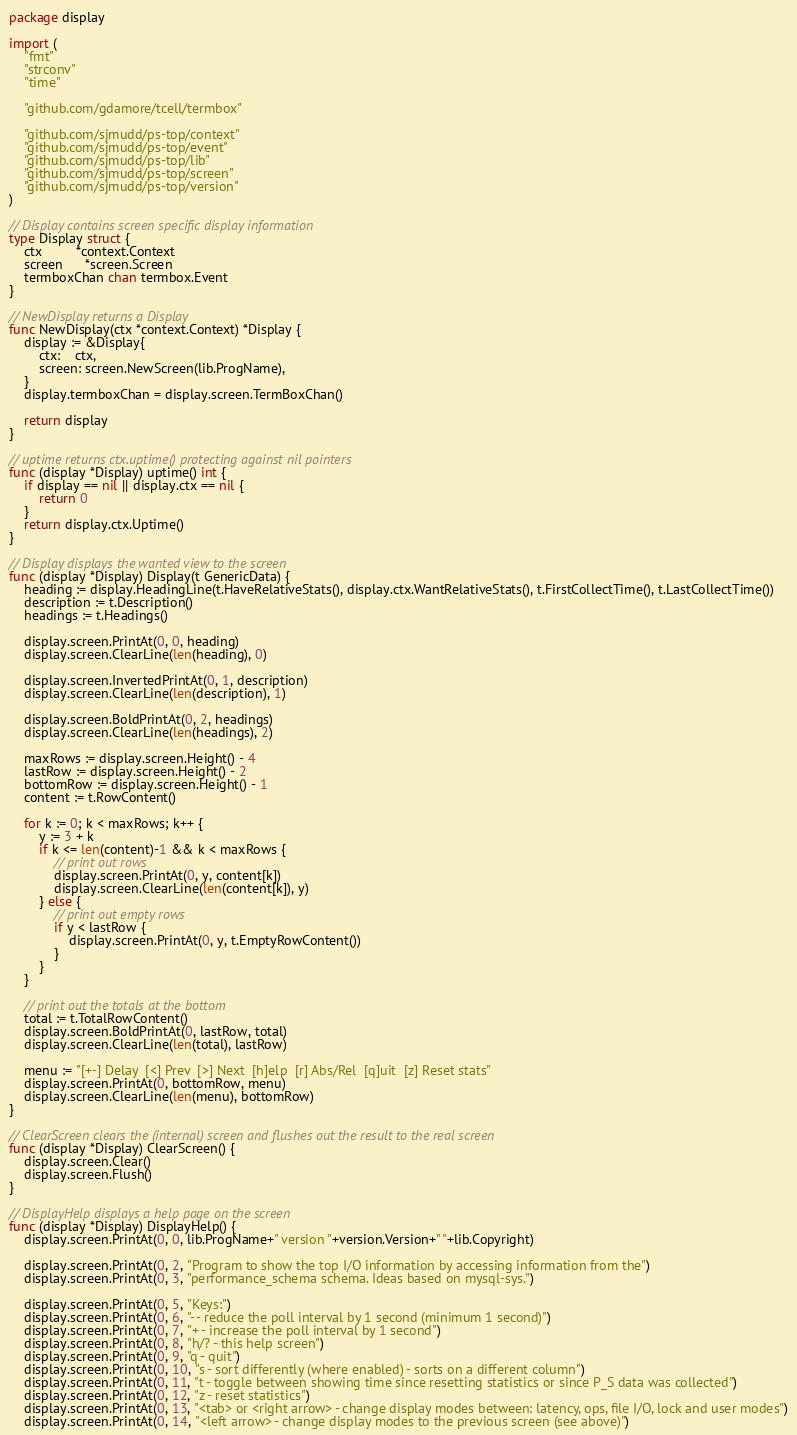Convert code to text. <code><loc_0><loc_0><loc_500><loc_500><_Go_>package display

import (
	"fmt"
	"strconv"
	"time"

	"github.com/gdamore/tcell/termbox"

	"github.com/sjmudd/ps-top/context"
	"github.com/sjmudd/ps-top/event"
	"github.com/sjmudd/ps-top/lib"
	"github.com/sjmudd/ps-top/screen"
	"github.com/sjmudd/ps-top/version"
)

// Display contains screen specific display information
type Display struct {
	ctx         *context.Context
	screen      *screen.Screen
	termboxChan chan termbox.Event
}

// NewDisplay returns a Display
func NewDisplay(ctx *context.Context) *Display {
	display := &Display{
		ctx:    ctx,
		screen: screen.NewScreen(lib.ProgName),
	}
	display.termboxChan = display.screen.TermBoxChan()

	return display
}

// uptime returns ctx.uptime() protecting against nil pointers
func (display *Display) uptime() int {
	if display == nil || display.ctx == nil {
		return 0
	}
	return display.ctx.Uptime()
}

// Display displays the wanted view to the screen
func (display *Display) Display(t GenericData) {
	heading := display.HeadingLine(t.HaveRelativeStats(), display.ctx.WantRelativeStats(), t.FirstCollectTime(), t.LastCollectTime())
	description := t.Description()
	headings := t.Headings()

	display.screen.PrintAt(0, 0, heading)
	display.screen.ClearLine(len(heading), 0)

	display.screen.InvertedPrintAt(0, 1, description)
	display.screen.ClearLine(len(description), 1)

	display.screen.BoldPrintAt(0, 2, headings)
	display.screen.ClearLine(len(headings), 2)

	maxRows := display.screen.Height() - 4
	lastRow := display.screen.Height() - 2
	bottomRow := display.screen.Height() - 1
	content := t.RowContent()

	for k := 0; k < maxRows; k++ {
		y := 3 + k
		if k <= len(content)-1 && k < maxRows {
			// print out rows
			display.screen.PrintAt(0, y, content[k])
			display.screen.ClearLine(len(content[k]), y)
		} else {
			// print out empty rows
			if y < lastRow {
				display.screen.PrintAt(0, y, t.EmptyRowContent())
			}
		}
	}

	// print out the totals at the bottom
	total := t.TotalRowContent()
	display.screen.BoldPrintAt(0, lastRow, total)
	display.screen.ClearLine(len(total), lastRow)

	menu := "[+-] Delay  [<] Prev  [>] Next  [h]elp  [r] Abs/Rel  [q]uit  [z] Reset stats"
	display.screen.PrintAt(0, bottomRow, menu)
	display.screen.ClearLine(len(menu), bottomRow)
}

// ClearScreen clears the (internal) screen and flushes out the result to the real screen
func (display *Display) ClearScreen() {
	display.screen.Clear()
	display.screen.Flush()
}

// DisplayHelp displays a help page on the screen
func (display *Display) DisplayHelp() {
	display.screen.PrintAt(0, 0, lib.ProgName+" version "+version.Version+" "+lib.Copyright)

	display.screen.PrintAt(0, 2, "Program to show the top I/O information by accessing information from the")
	display.screen.PrintAt(0, 3, "performance_schema schema. Ideas based on mysql-sys.")

	display.screen.PrintAt(0, 5, "Keys:")
	display.screen.PrintAt(0, 6, "- - reduce the poll interval by 1 second (minimum 1 second)")
	display.screen.PrintAt(0, 7, "+ - increase the poll interval by 1 second")
	display.screen.PrintAt(0, 8, "h/? - this help screen")
	display.screen.PrintAt(0, 9, "q - quit")
	display.screen.PrintAt(0, 10, "s - sort differently (where enabled) - sorts on a different column")
	display.screen.PrintAt(0, 11, "t - toggle between showing time since resetting statistics or since P_S data was collected")
	display.screen.PrintAt(0, 12, "z - reset statistics")
	display.screen.PrintAt(0, 13, "<tab> or <right arrow> - change display modes between: latency, ops, file I/O, lock and user modes")
	display.screen.PrintAt(0, 14, "<left arrow> - change display modes to the previous screen (see above)")</code> 